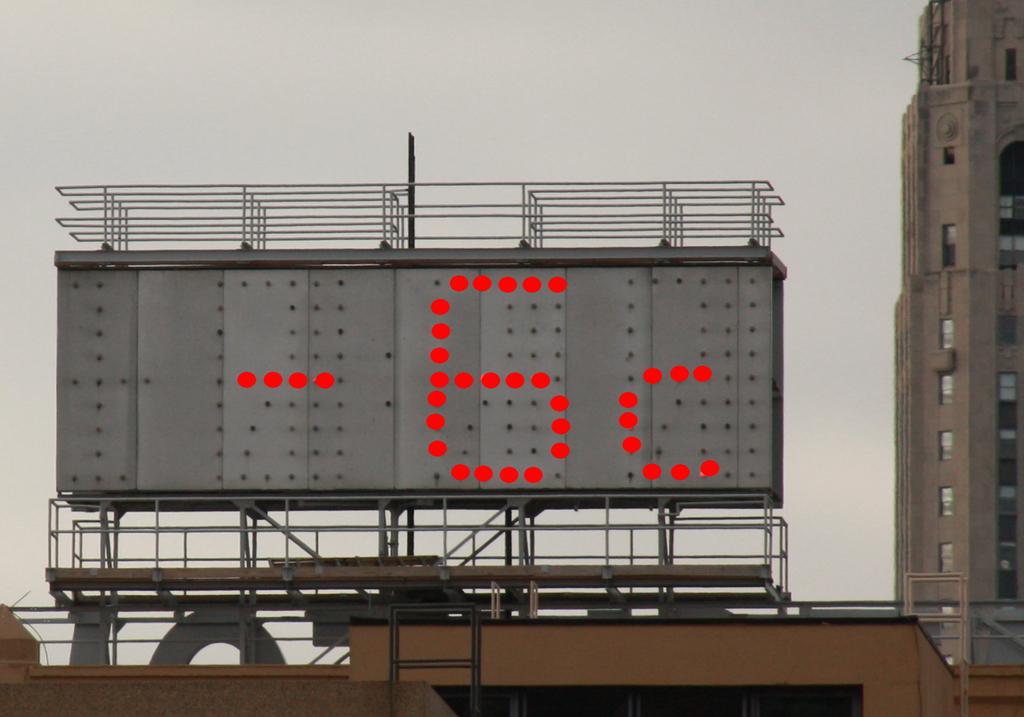What is the temperature shown here?
Your answer should be very brief. -6c. 